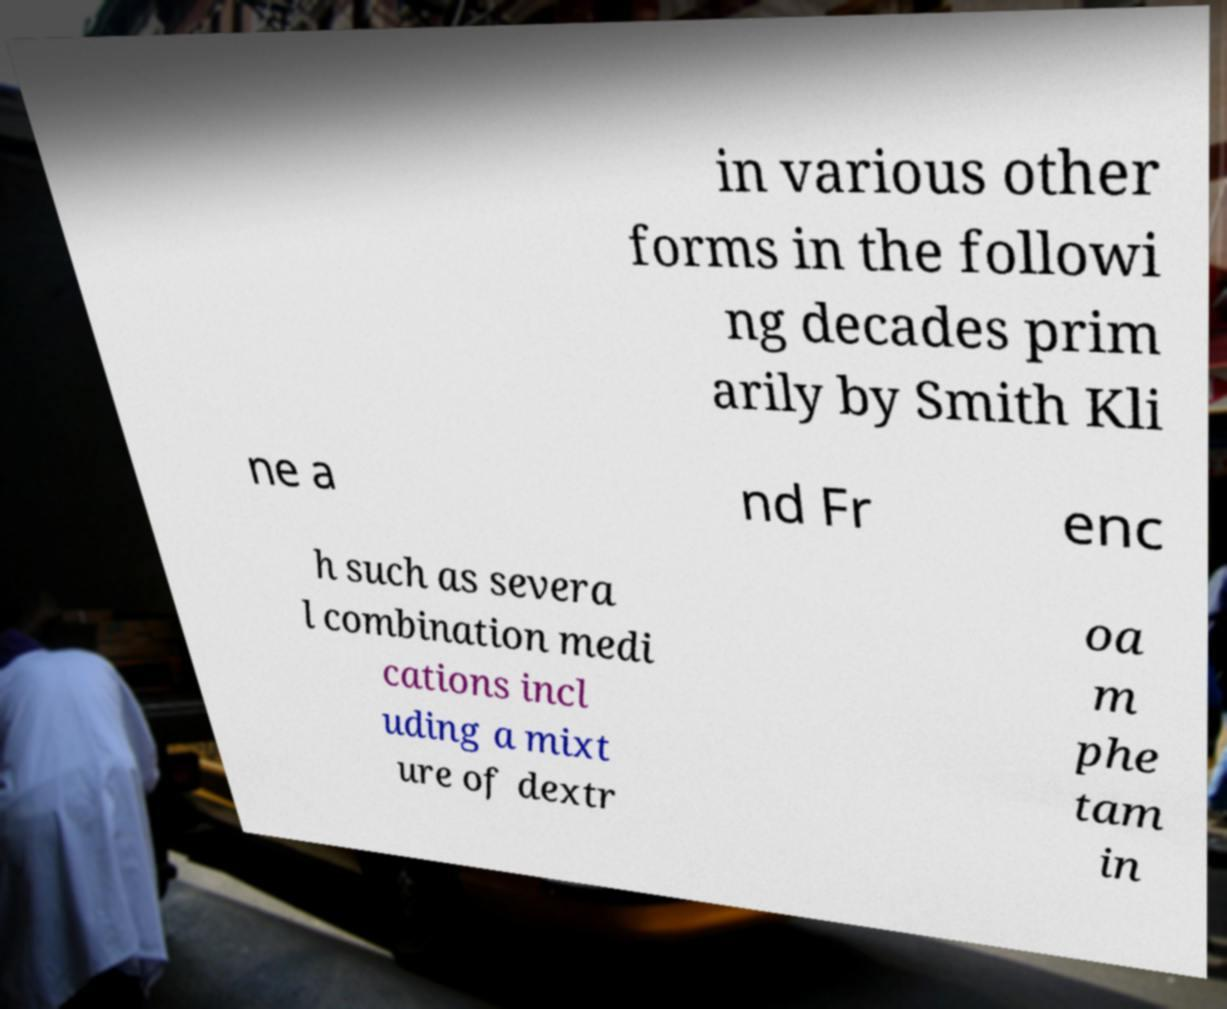Please read and relay the text visible in this image. What does it say? in various other forms in the followi ng decades prim arily by Smith Kli ne a nd Fr enc h such as severa l combination medi cations incl uding a mixt ure of dextr oa m phe tam in 